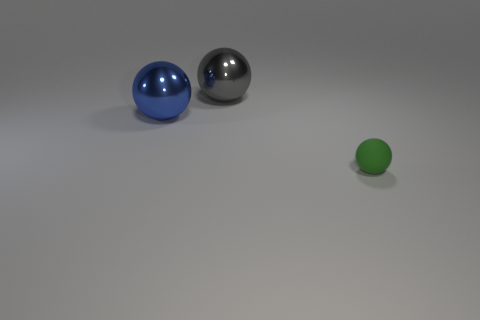Are there fewer blue objects right of the green sphere than big gray metal spheres that are right of the blue ball?
Your answer should be compact. Yes. Do the rubber ball and the gray object have the same size?
Make the answer very short. No. There is a object that is behind the tiny object and to the right of the big blue metallic thing; what shape is it?
Offer a very short reply. Sphere. What number of spheres have the same material as the gray object?
Make the answer very short. 1. What number of big metallic objects are in front of the thing that is behind the big blue shiny thing?
Make the answer very short. 1. What shape is the thing left of the large metallic ball that is behind the large shiny object in front of the gray metallic thing?
Ensure brevity in your answer.  Sphere. How many objects are either big metallic balls or big cyan blocks?
Give a very brief answer. 2. There is another metallic sphere that is the same size as the blue sphere; what color is it?
Offer a very short reply. Gray. There is a matte thing; does it have the same shape as the large metal object that is right of the blue sphere?
Give a very brief answer. Yes. What number of things are big gray things to the right of the blue object or spheres in front of the big gray shiny sphere?
Keep it short and to the point. 3. 